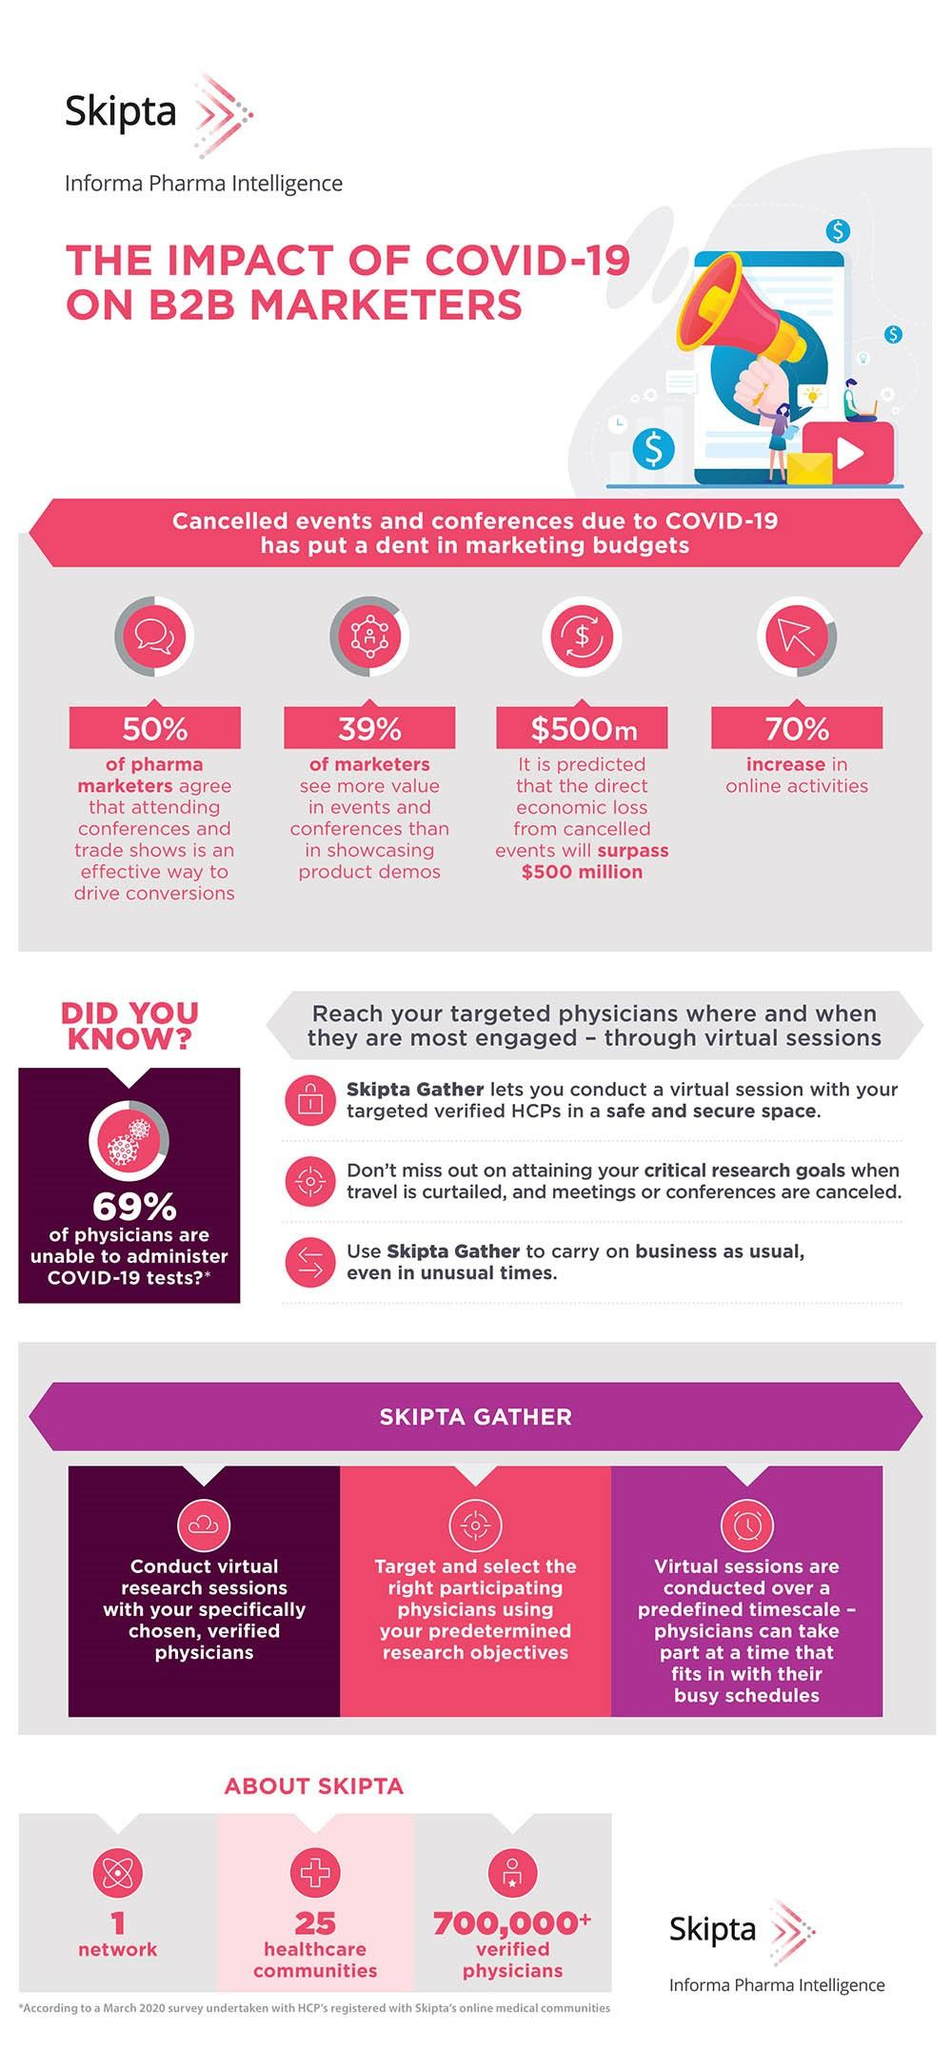Outline some significant characteristics in this image. There are 25 healthcare communities. I, [person], affirm that there is only one network, numbered 1, and any other networks that may exist are not valid. According to a survey of pharmaceutical marketing professionals, 50% believe that attending conferences and trade shows is an effective way to drive conversions. A recent survey found that 39% of marketers believe that events and conferences offer more value than product demos in showcasing their brand. 